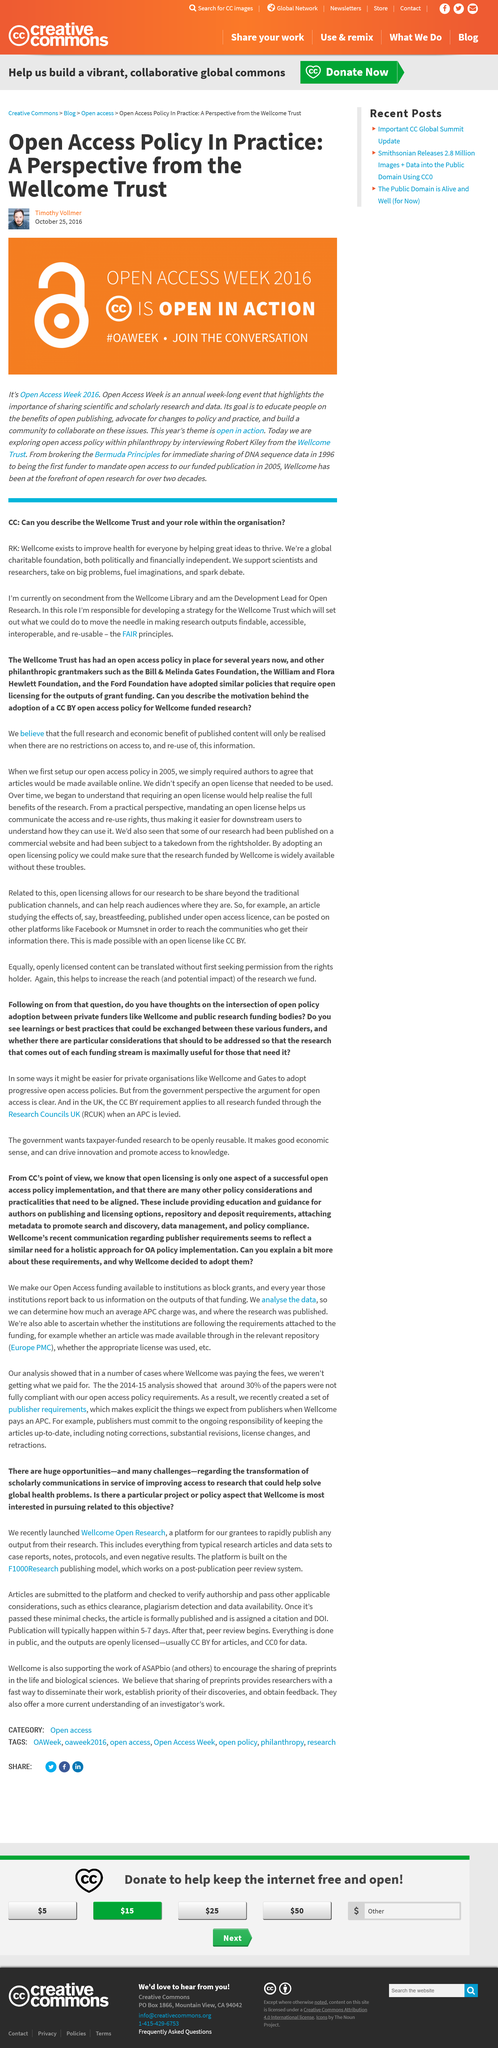Highlight a few significant elements in this photo. It takes approximately 5-7 days for articles published on Wellcome Open Research to be published. The Wellcome Open Research platform was launched by an organization called Wellcome. Open Access Week is a designated week to celebrate and promote the principles of open access to information and research. The hashtag #OAWEEK is short for Open Access Week and is used to promote and raise awareness about open access initiatives and resources. After publication, an article must undergo peer review. It is stated in the text that Timothy Vollmer will be interviewing Robert Kiley from the Wellcome Trust to explore the open access policy within philanthropy. 